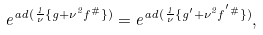<formula> <loc_0><loc_0><loc_500><loc_500>e ^ { a d ( \frac { 1 } { \nu } \{ g + \nu ^ { 2 } f ^ { \# } \} ) } = e ^ { a d ( \frac { 1 } { \nu } \{ g ^ { \prime } + \nu ^ { 2 } f ^ { ^ { \prime } \# } \} ) } ,</formula> 